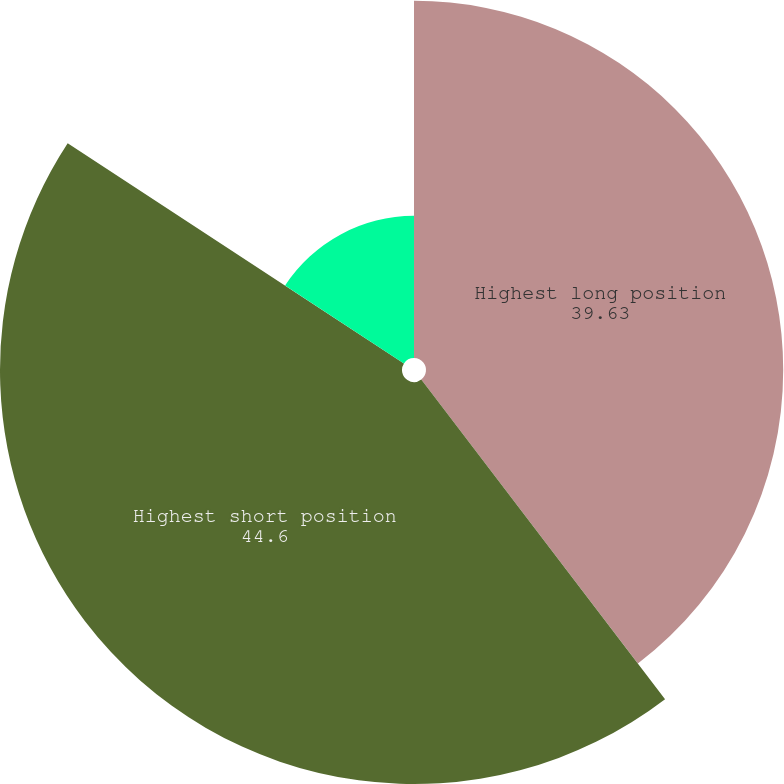<chart> <loc_0><loc_0><loc_500><loc_500><pie_chart><fcel>Highest long position<fcel>Highest short position<fcel>Average position long (short)<nl><fcel>39.63%<fcel>44.6%<fcel>15.77%<nl></chart> 